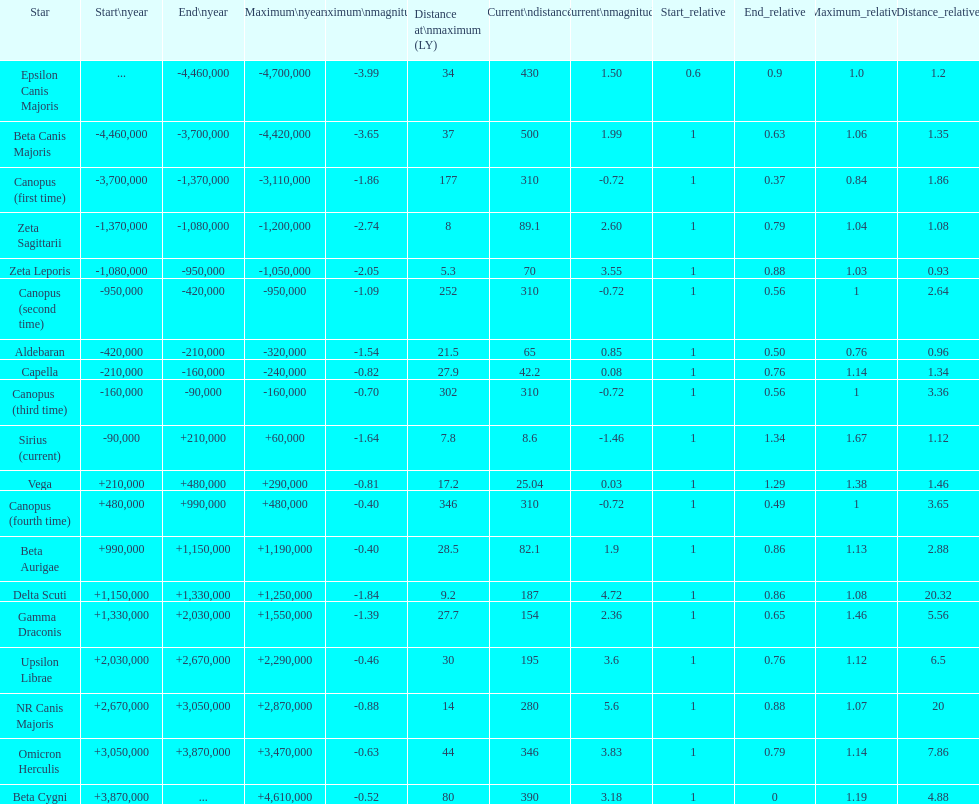What is the difference in the nearest current distance and farthest current distance? 491.4. 